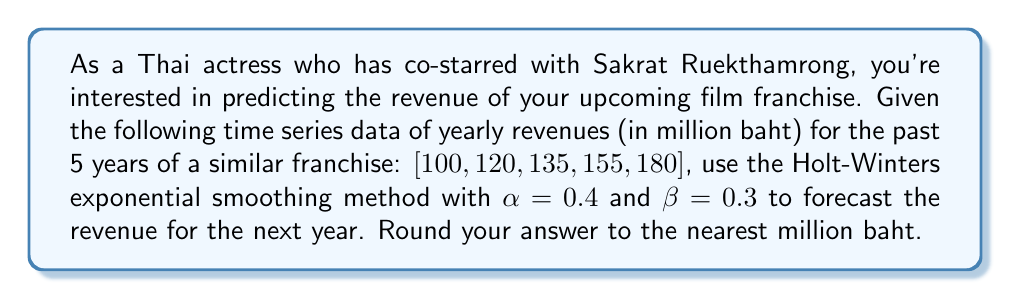Can you answer this question? The Holt-Winters exponential smoothing method for trend forecasting involves two equations:

1. Level equation: $L_t = \alpha Y_t + (1-\alpha)(L_{t-1} + T_{t-1})$
2. Trend equation: $T_t = \beta(L_t - L_{t-1}) + (1-\beta)T_{t-1}$

Where:
$L_t$ is the level at time $t$
$T_t$ is the trend at time $t$
$Y_t$ is the observed value at time $t$
$\alpha$ and $\beta$ are smoothing parameters

Step 1: Initialize $L_0$ and $T_0$
$L_0 = 100$ (first observation)
$T_0 = 20$ (average of first-order differences)

Step 2: Calculate for each time period
For t = 1:
$L_1 = 0.4(120) + (1-0.4)(100 + 20) = 108$
$T_1 = 0.3(108 - 100) + (1-0.3)(20) = 16.4$

For t = 2:
$L_2 = 0.4(135) + (1-0.4)(108 + 16.4) = 128.24$
$T_2 = 0.3(128.24 - 108) + (1-0.3)(16.4) = 17.472$

For t = 3:
$L_3 = 0.4(155) + (1-0.4)(128.24 + 17.472) = 149.5888$
$T_3 = 0.3(149.5888 - 128.24) + (1-0.3)(17.472) = 19.5446$

For t = 4:
$L_4 = 0.4(180) + (1-0.4)(149.5888 + 19.5446) = 174.08$
$T_4 = 0.3(174.08 - 149.5888) + (1-0.3)(19.5446) = 21.1458$

Step 3: Forecast for t = 5 (next year)
$F_5 = L_4 + T_4 = 174.08 + 21.1458 = 195.2258$

Step 4: Round to the nearest million baht
195.2258 million baht ≈ 195 million baht
Answer: 195 million baht 